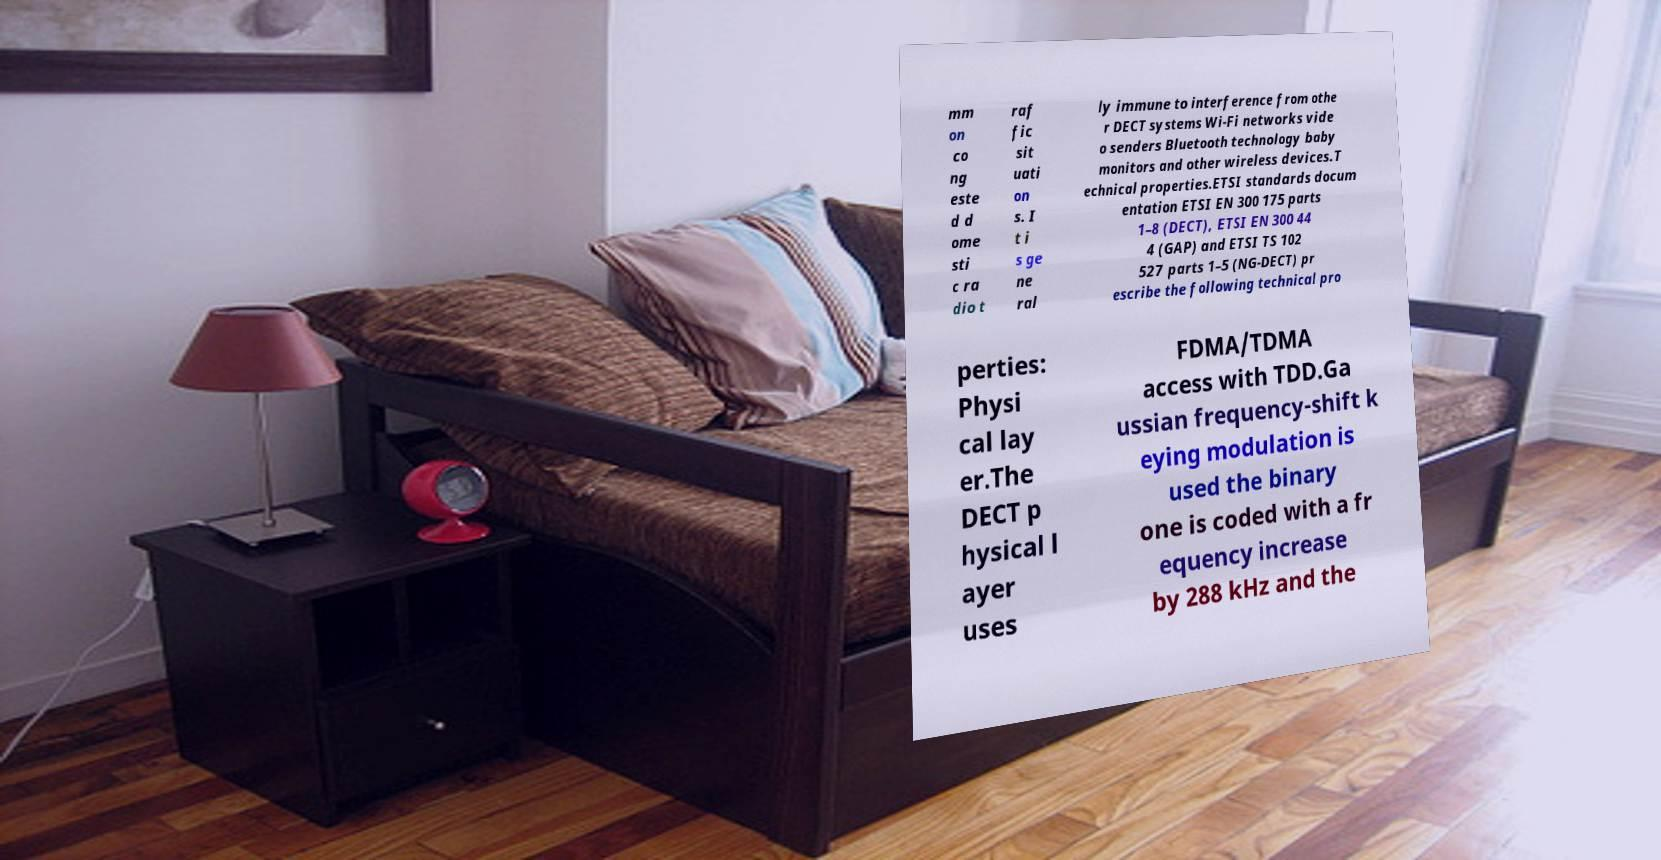I need the written content from this picture converted into text. Can you do that? mm on co ng este d d ome sti c ra dio t raf fic sit uati on s. I t i s ge ne ral ly immune to interference from othe r DECT systems Wi-Fi networks vide o senders Bluetooth technology baby monitors and other wireless devices.T echnical properties.ETSI standards docum entation ETSI EN 300 175 parts 1–8 (DECT), ETSI EN 300 44 4 (GAP) and ETSI TS 102 527 parts 1–5 (NG-DECT) pr escribe the following technical pro perties: Physi cal lay er.The DECT p hysical l ayer uses FDMA/TDMA access with TDD.Ga ussian frequency-shift k eying modulation is used the binary one is coded with a fr equency increase by 288 kHz and the 